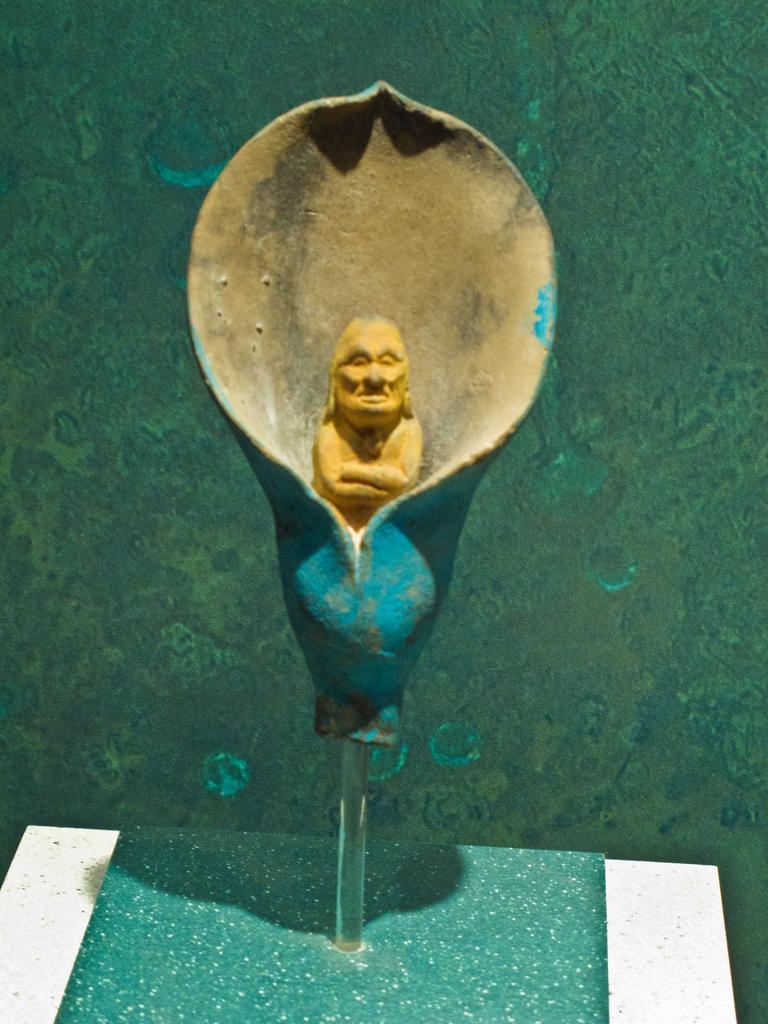Please provide a concise description of this image. There is a statue in the middle of this image and there is a wall in the background. 